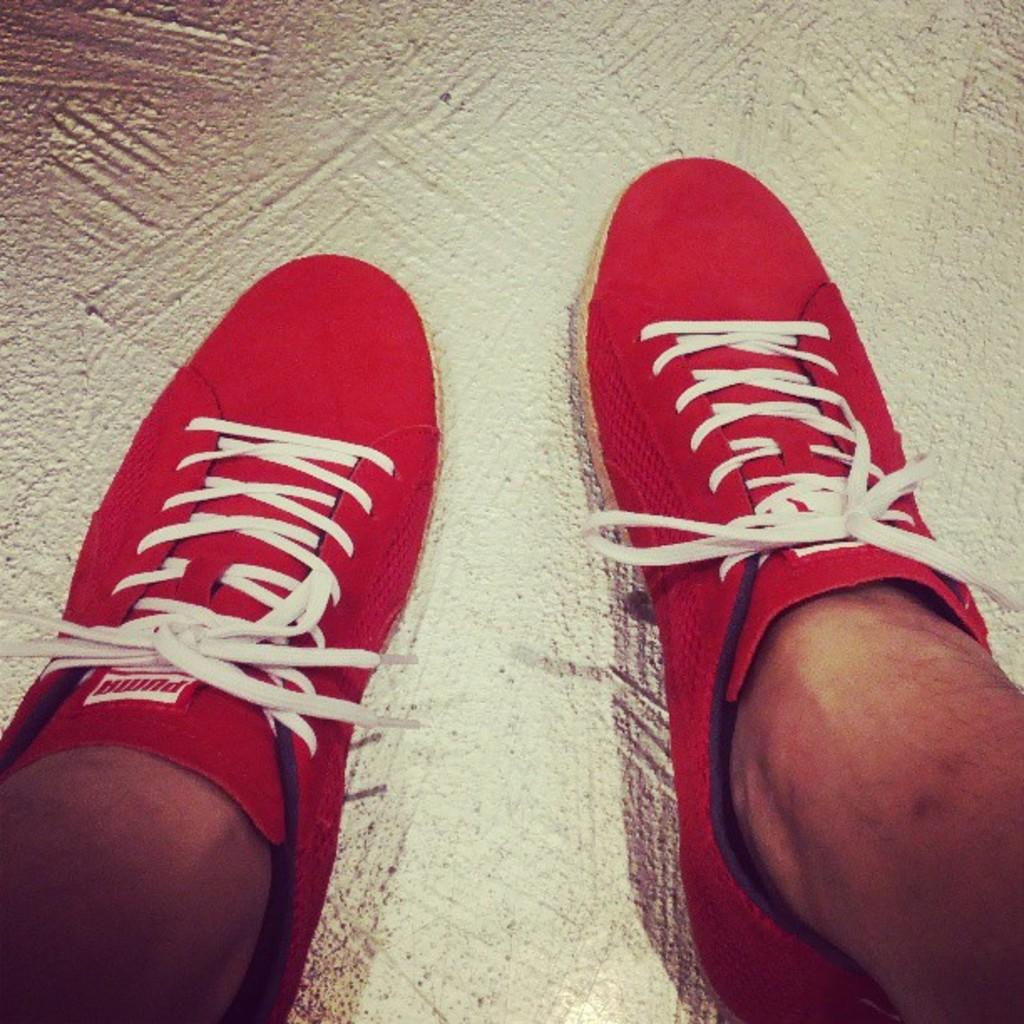Who or what is present in the image? There is a person in the image. What can be observed about the person's shoes? The person is wearing red shoes. What is the color of the surface on which the shoes are placed? The shoes are placed on a white surface. What type of horn can be seen on the person's head in the image? There is no horn present on the person's head in the image. 